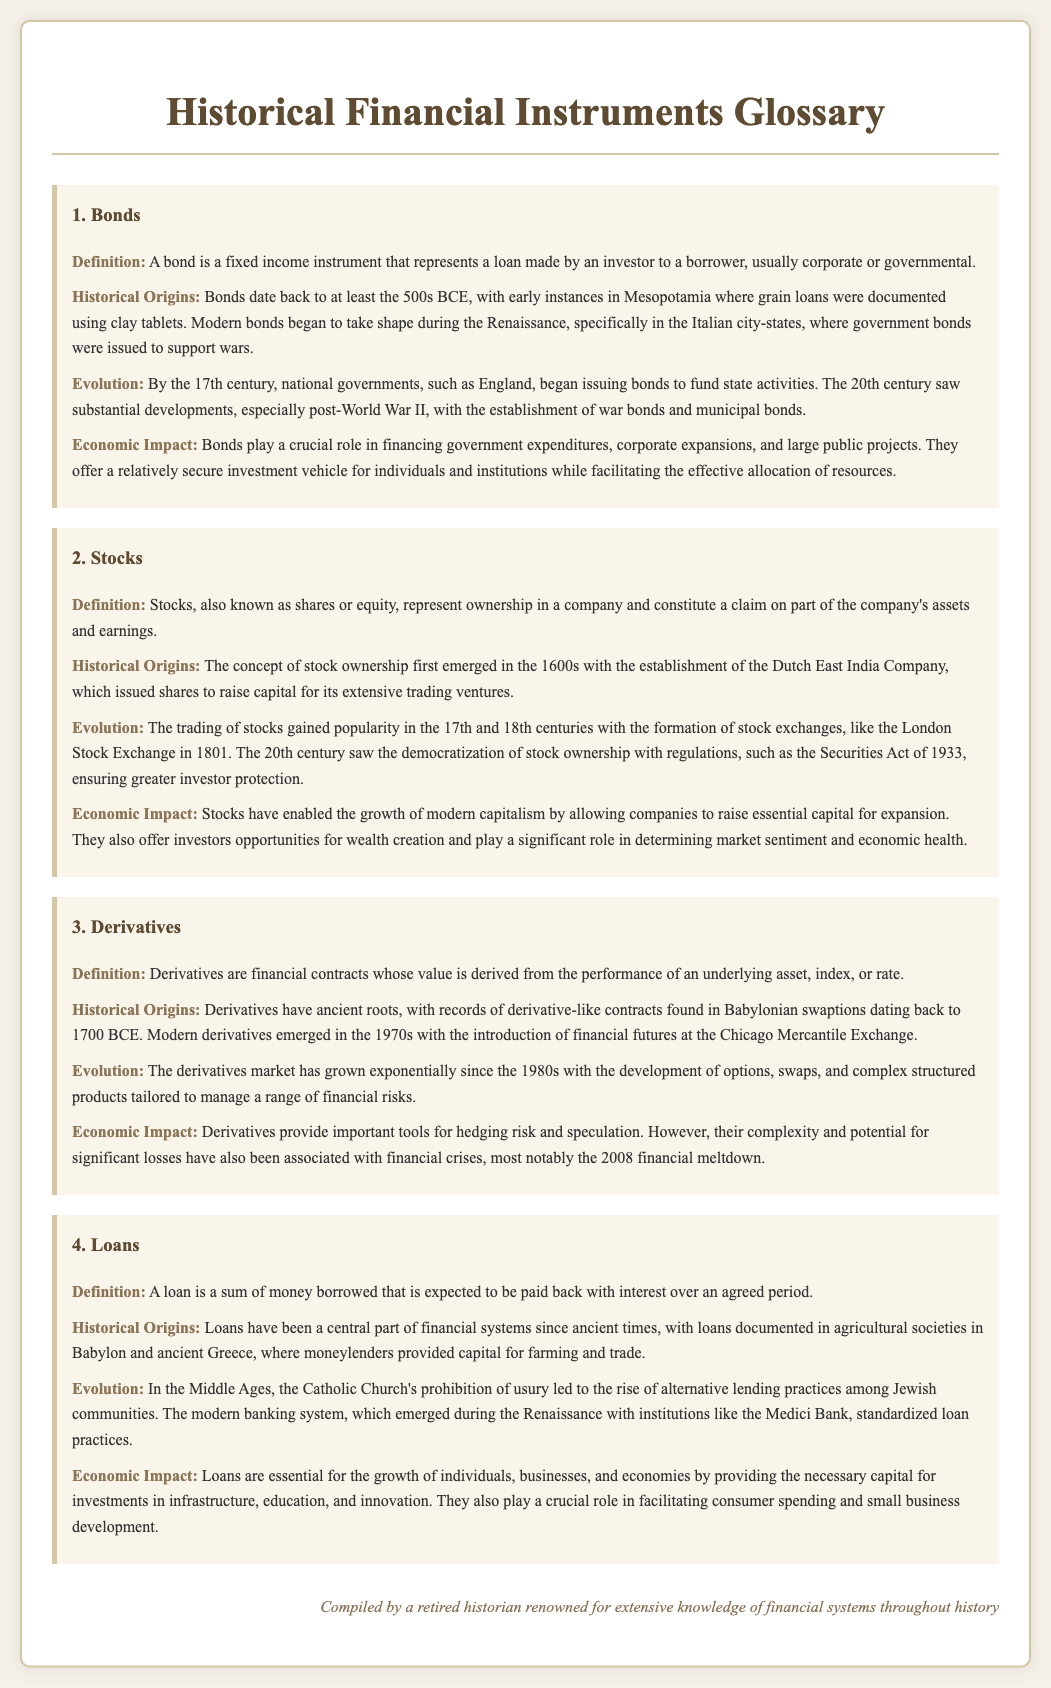What are bonds? Bonds are defined in the document as fixed income instruments representing a loan made by an investor to a borrower.
Answer: A fixed income instrument What historical period marks the origin of stocks? The historical origins of stocks are traced back to the 1600s with the establishment of the Dutch East India Company.
Answer: 1600s Which financial instruments significantly emerged in the 1970s? The document specifies that modern derivatives emerged in the 1970s with the introduction of financial futures.
Answer: Derivatives What was a primary reason for the rise of alternative lending practices in the Middle Ages? The document states that the Catholic Church's prohibition of usury prompted the rise of alternative lending practices.
Answer: Prohibition of usury How do derivatives provide economic utility? The economic impact of derivatives is discussed in the context of their role in hedging risk and speculation.
Answer: Hedging risk and speculation What major financial event is associated with derivatives? The document mentions that derivatives were notably associated with the 2008 financial meltdown.
Answer: 2008 financial meltdown In which region were early recorded bonds issued? The historical origins reveal that bonds were early recorded in Mesopotamia using clay tablets.
Answer: Mesopotamia What type of financial vehicle do bonds represent? The document describes bonds as a relatively secure investment vehicle for individuals and institutions.
Answer: Investment vehicle 